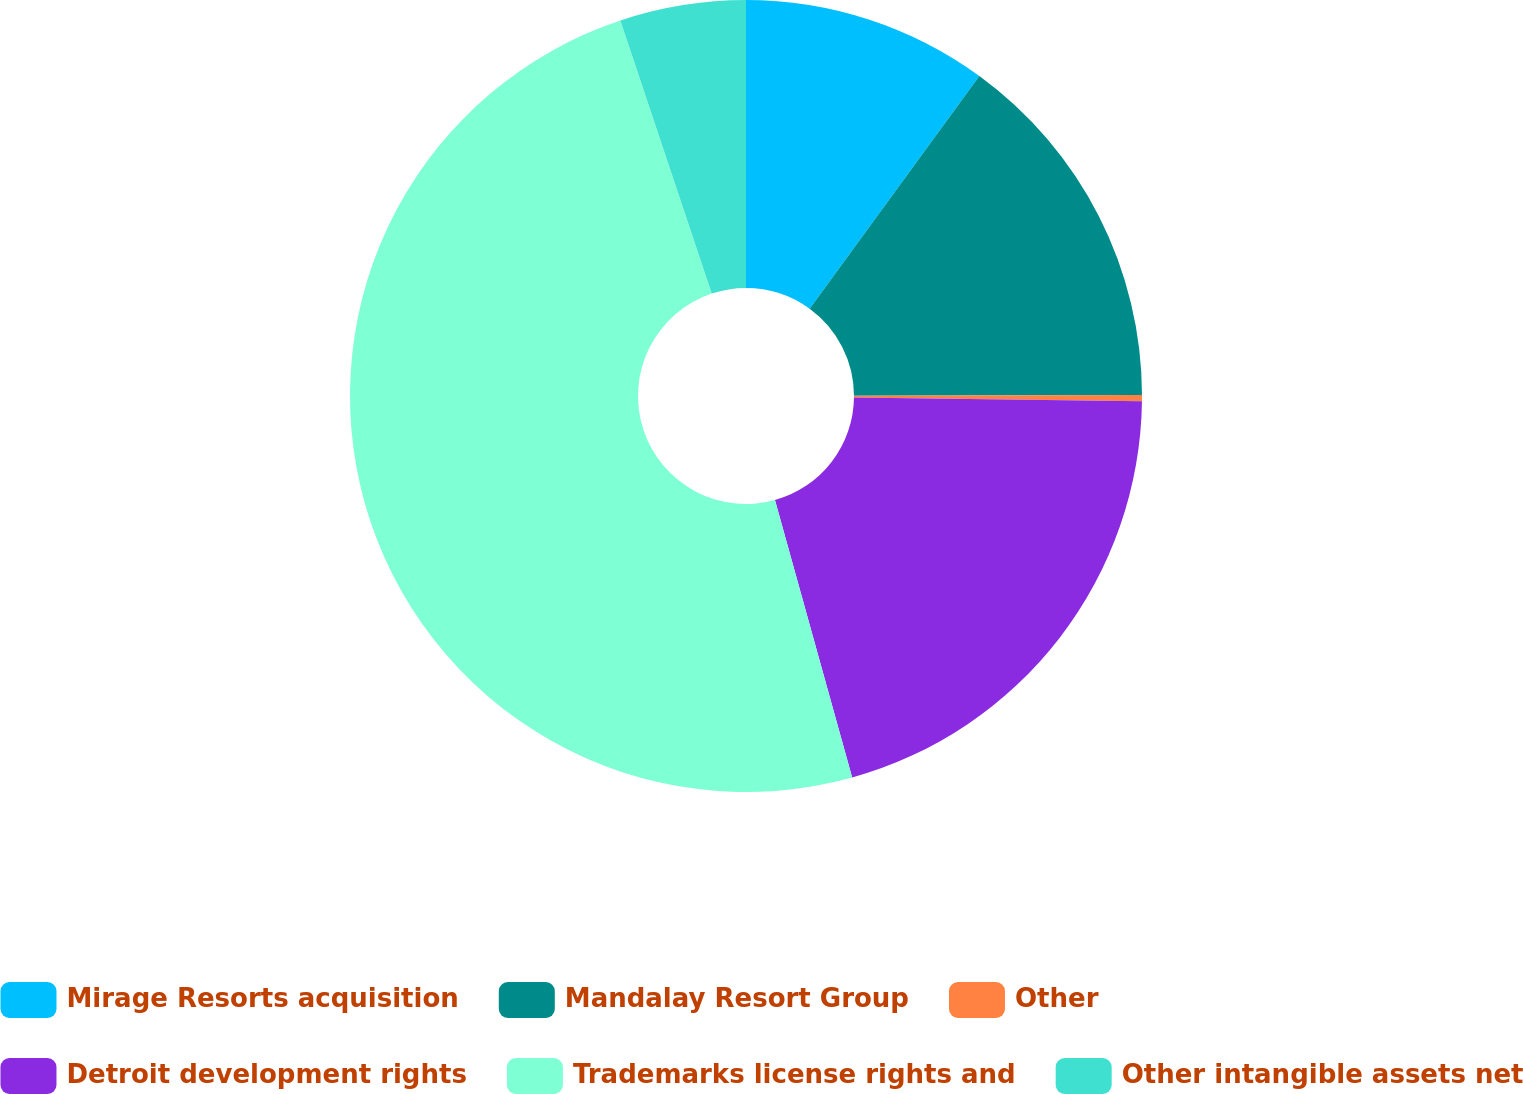Convert chart to OTSL. <chart><loc_0><loc_0><loc_500><loc_500><pie_chart><fcel>Mirage Resorts acquisition<fcel>Mandalay Resort Group<fcel>Other<fcel>Detroit development rights<fcel>Trademarks license rights and<fcel>Other intangible assets net<nl><fcel>10.03%<fcel>14.93%<fcel>0.25%<fcel>20.47%<fcel>49.18%<fcel>5.14%<nl></chart> 